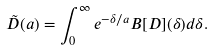<formula> <loc_0><loc_0><loc_500><loc_500>\tilde { D } ( a ) = \int _ { 0 } ^ { \infty } e ^ { - \delta / a } B [ D ] ( \delta ) d \delta .</formula> 